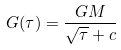<formula> <loc_0><loc_0><loc_500><loc_500>G ( \tau ) = \frac { G M } { \sqrt { \tau } + c }</formula> 